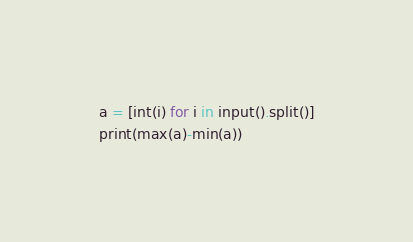<code> <loc_0><loc_0><loc_500><loc_500><_Python_>a = [int(i) for i in input().split()]
print(max(a)-min(a))</code> 